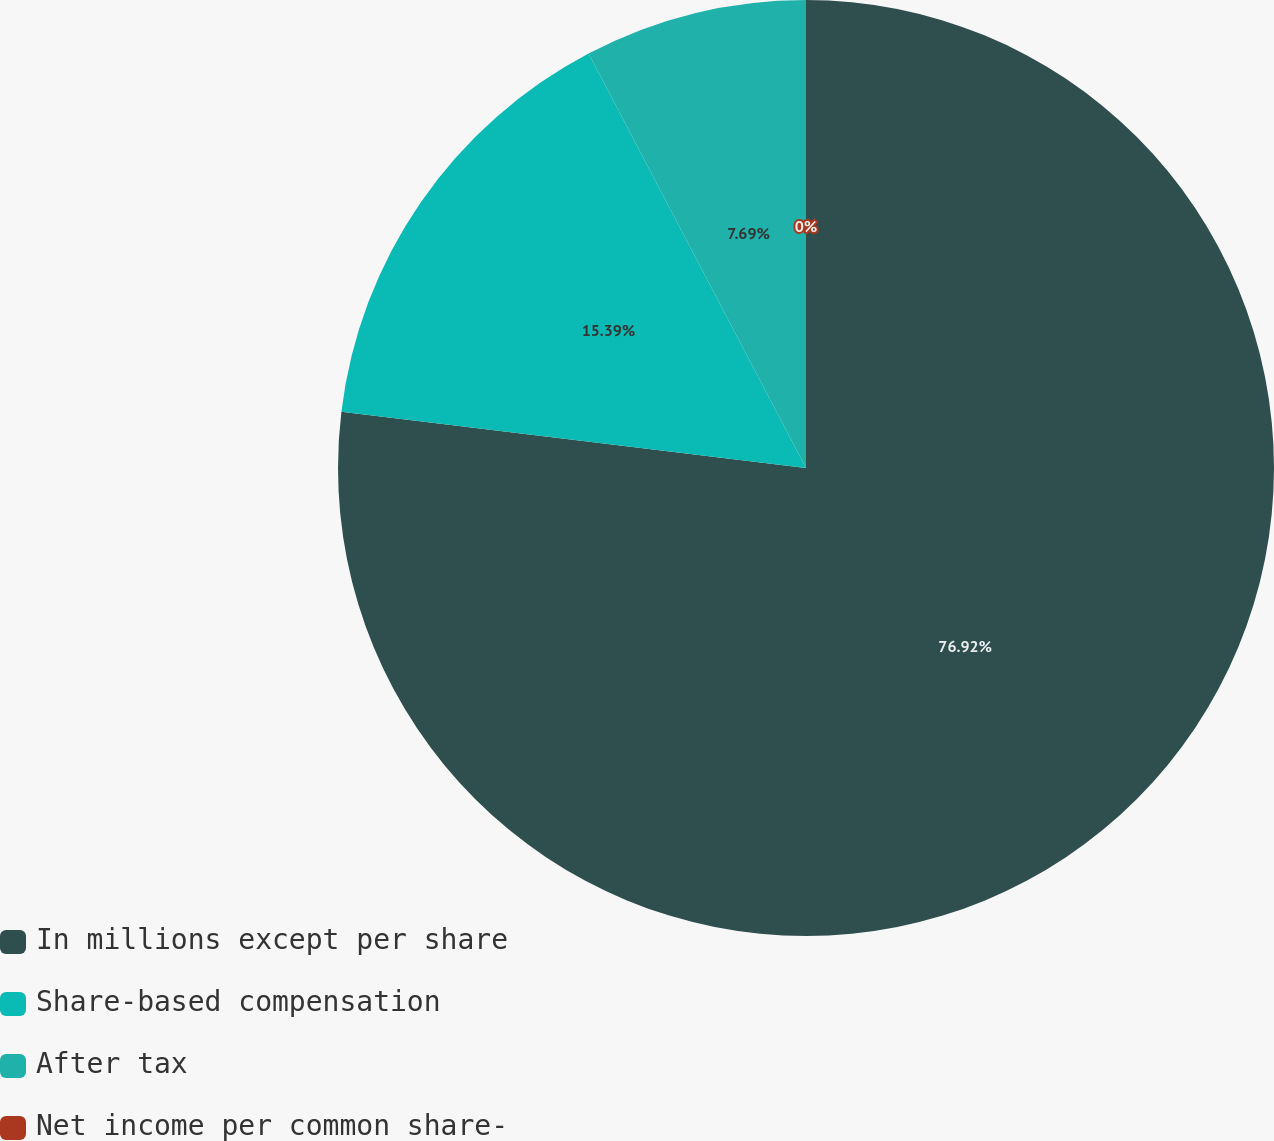<chart> <loc_0><loc_0><loc_500><loc_500><pie_chart><fcel>In millions except per share<fcel>Share-based compensation<fcel>After tax<fcel>Net income per common share-<nl><fcel>76.92%<fcel>15.39%<fcel>7.69%<fcel>0.0%<nl></chart> 